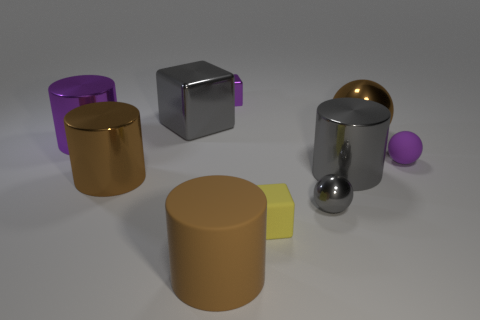Subtract all big shiny blocks. How many blocks are left? 2 Subtract all purple blocks. How many blocks are left? 2 Subtract all cylinders. How many objects are left? 6 Subtract 2 balls. How many balls are left? 1 Add 3 cylinders. How many cylinders exist? 7 Subtract 0 yellow balls. How many objects are left? 10 Subtract all gray cylinders. Subtract all yellow cubes. How many cylinders are left? 3 Subtract all gray cubes. How many gray balls are left? 1 Subtract all big brown rubber cylinders. Subtract all tiny gray shiny balls. How many objects are left? 8 Add 4 brown metal cylinders. How many brown metal cylinders are left? 5 